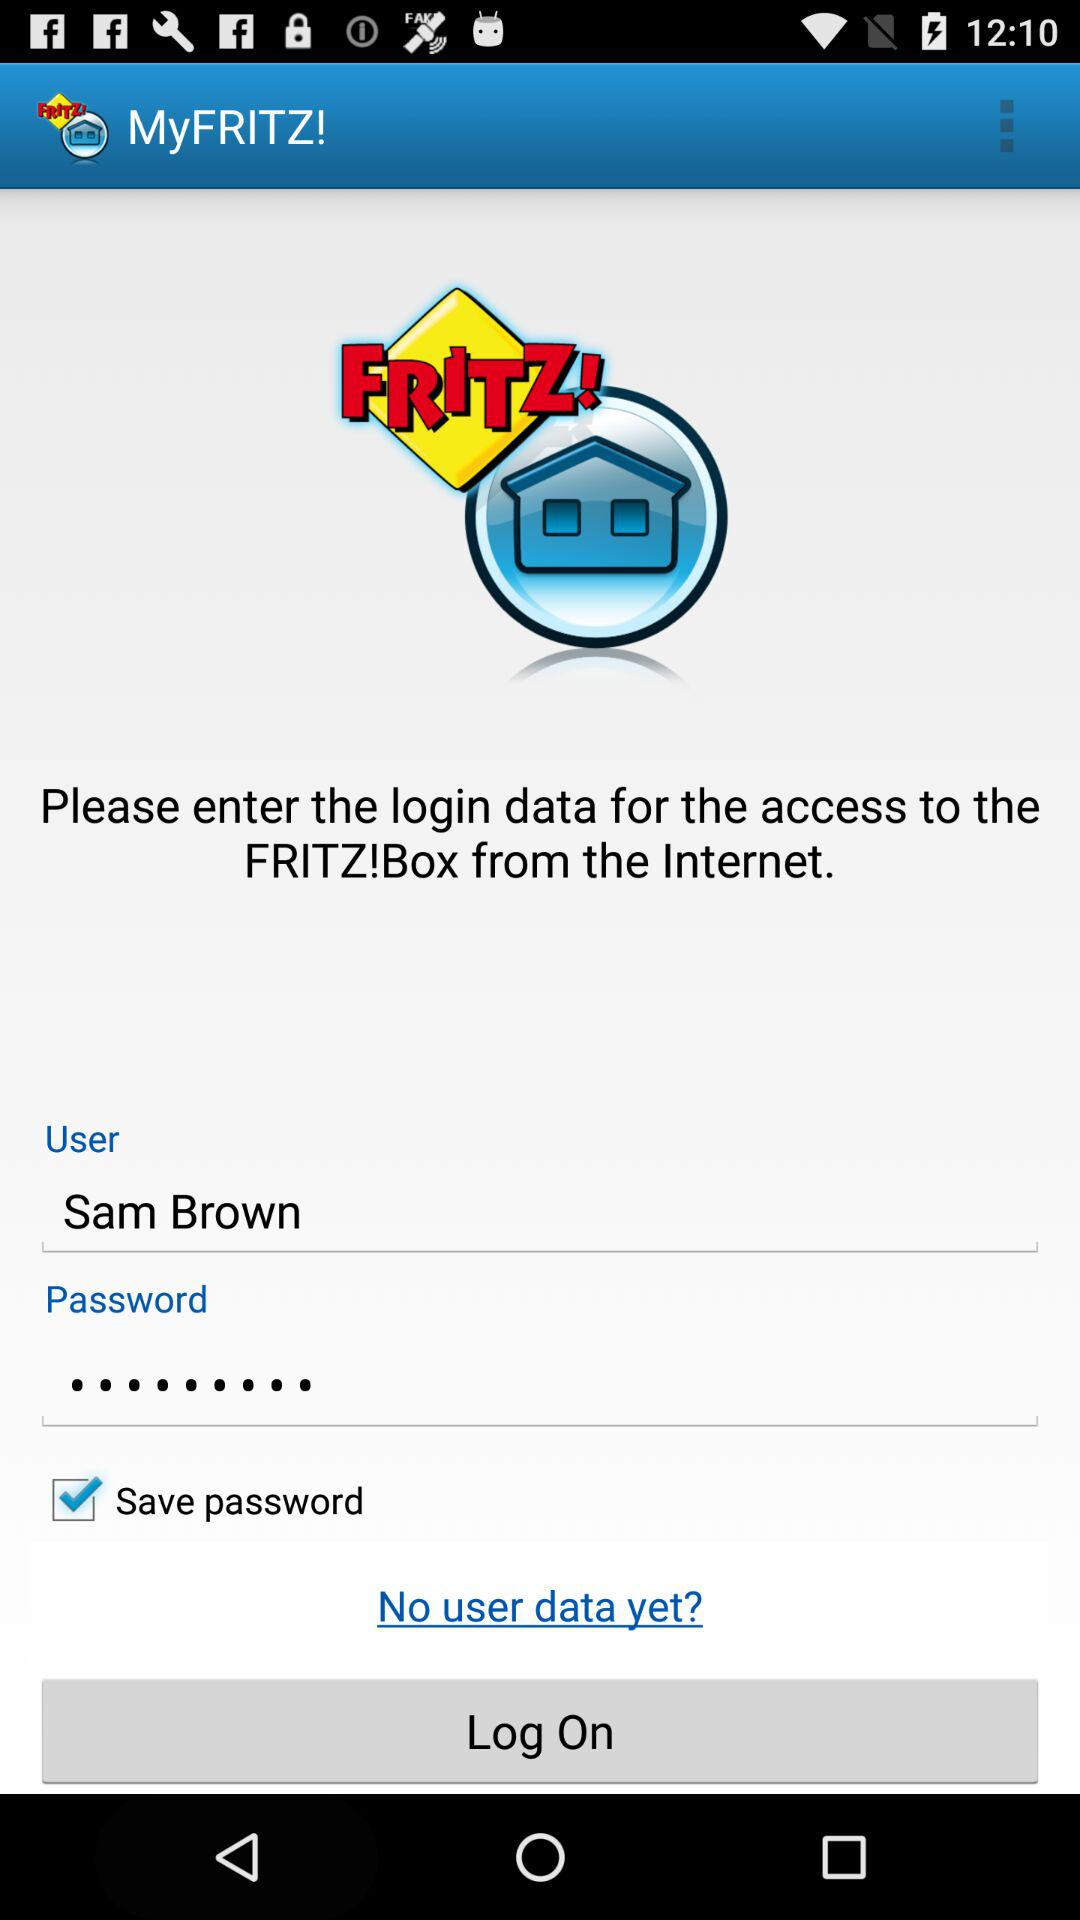What is the status of "Save password"? The status is "on". 